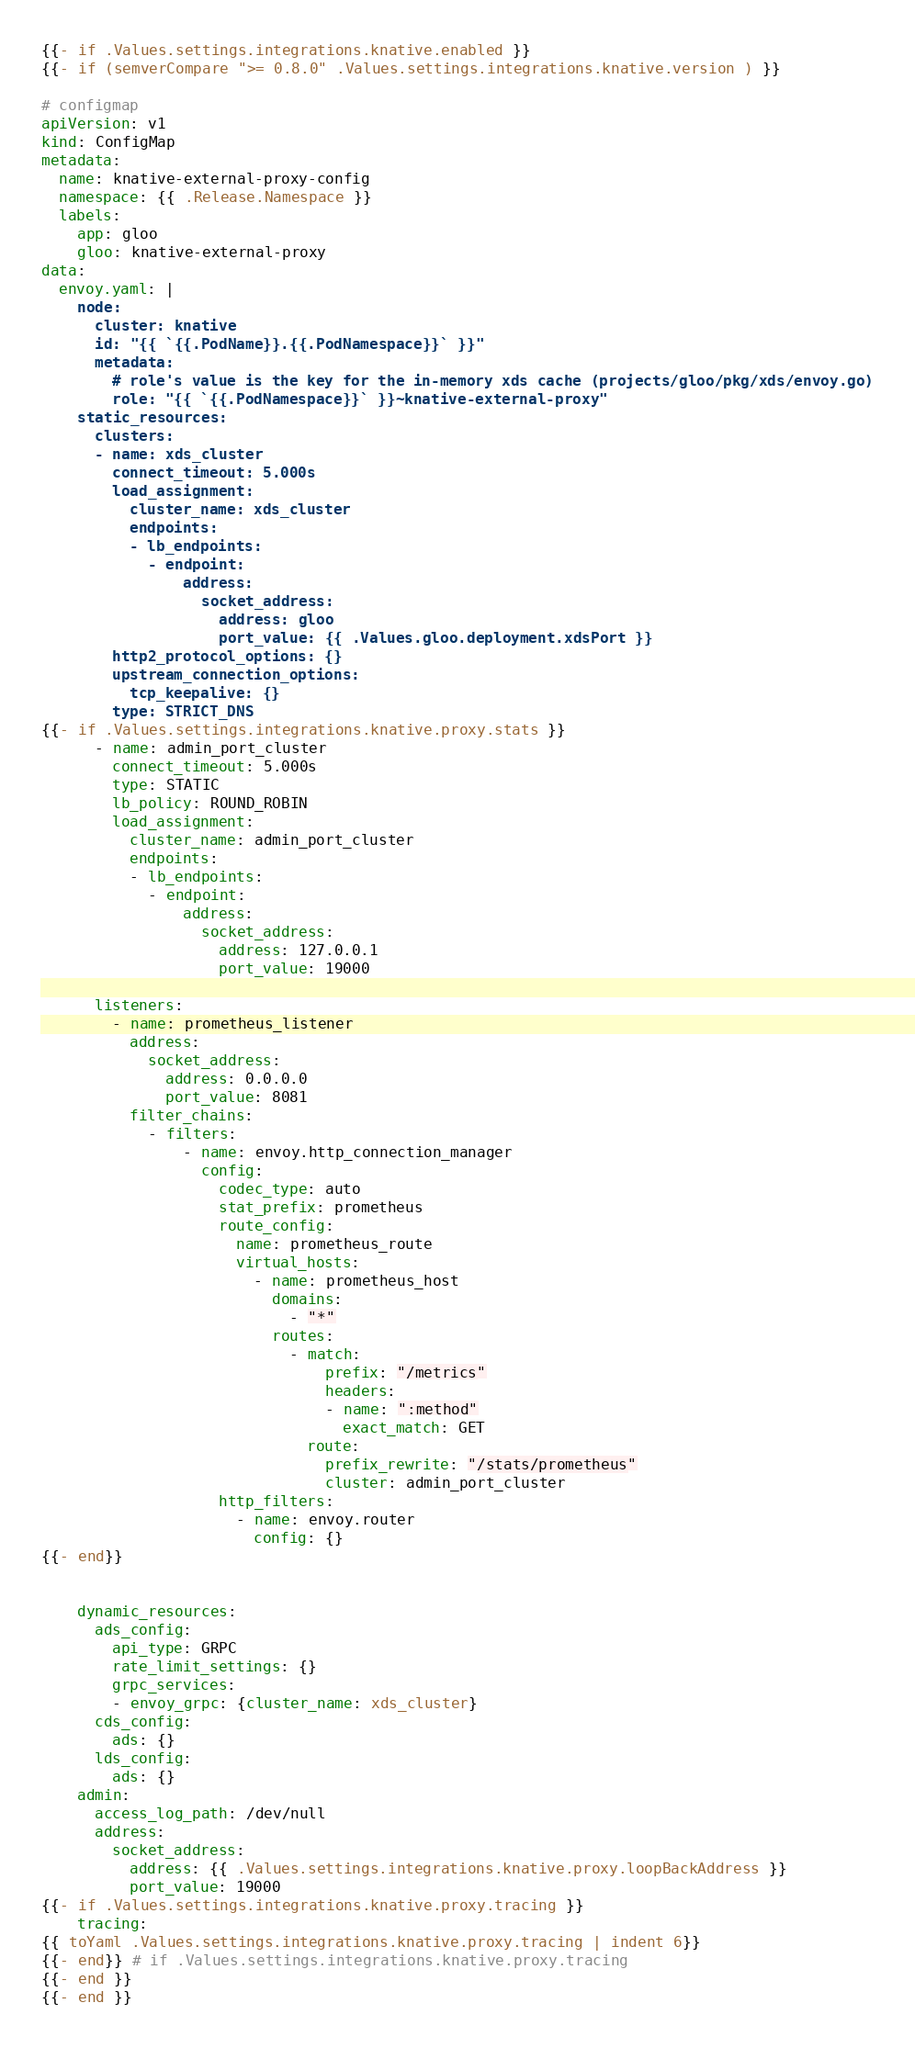Convert code to text. <code><loc_0><loc_0><loc_500><loc_500><_YAML_>{{- if .Values.settings.integrations.knative.enabled }}
{{- if (semverCompare ">= 0.8.0" .Values.settings.integrations.knative.version ) }}

# configmap
apiVersion: v1
kind: ConfigMap
metadata:
  name: knative-external-proxy-config
  namespace: {{ .Release.Namespace }}
  labels:
    app: gloo
    gloo: knative-external-proxy
data:
  envoy.yaml: |
    node:
      cluster: knative
      id: "{{ `{{.PodName}}.{{.PodNamespace}}` }}"
      metadata:
        # role's value is the key for the in-memory xds cache (projects/gloo/pkg/xds/envoy.go)
        role: "{{ `{{.PodNamespace}}` }}~knative-external-proxy"
    static_resources:
      clusters:
      - name: xds_cluster
        connect_timeout: 5.000s
        load_assignment:
          cluster_name: xds_cluster
          endpoints:
          - lb_endpoints:
            - endpoint:
                address:
                  socket_address:
                    address: gloo
                    port_value: {{ .Values.gloo.deployment.xdsPort }}
        http2_protocol_options: {}
        upstream_connection_options:
          tcp_keepalive: {}
        type: STRICT_DNS
{{- if .Values.settings.integrations.knative.proxy.stats }}
      - name: admin_port_cluster
        connect_timeout: 5.000s
        type: STATIC
        lb_policy: ROUND_ROBIN
        load_assignment:
          cluster_name: admin_port_cluster
          endpoints:
          - lb_endpoints:
            - endpoint:
                address:
                  socket_address:
                    address: 127.0.0.1
                    port_value: 19000

      listeners:
        - name: prometheus_listener
          address:
            socket_address:
              address: 0.0.0.0
              port_value: 8081
          filter_chains:
            - filters:
                - name: envoy.http_connection_manager
                  config:
                    codec_type: auto
                    stat_prefix: prometheus
                    route_config:
                      name: prometheus_route
                      virtual_hosts:
                        - name: prometheus_host
                          domains:
                            - "*"
                          routes:
                            - match:
                                prefix: "/metrics"
                                headers:
                                - name: ":method"
                                  exact_match: GET
                              route:
                                prefix_rewrite: "/stats/prometheus"
                                cluster: admin_port_cluster
                    http_filters:
                      - name: envoy.router
                        config: {}
{{- end}}


    dynamic_resources:
      ads_config:
        api_type: GRPC
        rate_limit_settings: {}
        grpc_services:
        - envoy_grpc: {cluster_name: xds_cluster}
      cds_config:
        ads: {}
      lds_config:
        ads: {}
    admin:
      access_log_path: /dev/null
      address:
        socket_address:
          address: {{ .Values.settings.integrations.knative.proxy.loopBackAddress }}
          port_value: 19000
{{- if .Values.settings.integrations.knative.proxy.tracing }}
    tracing:
{{ toYaml .Values.settings.integrations.knative.proxy.tracing | indent 6}}
{{- end}} # if .Values.settings.integrations.knative.proxy.tracing
{{- end }}
{{- end }}
</code> 